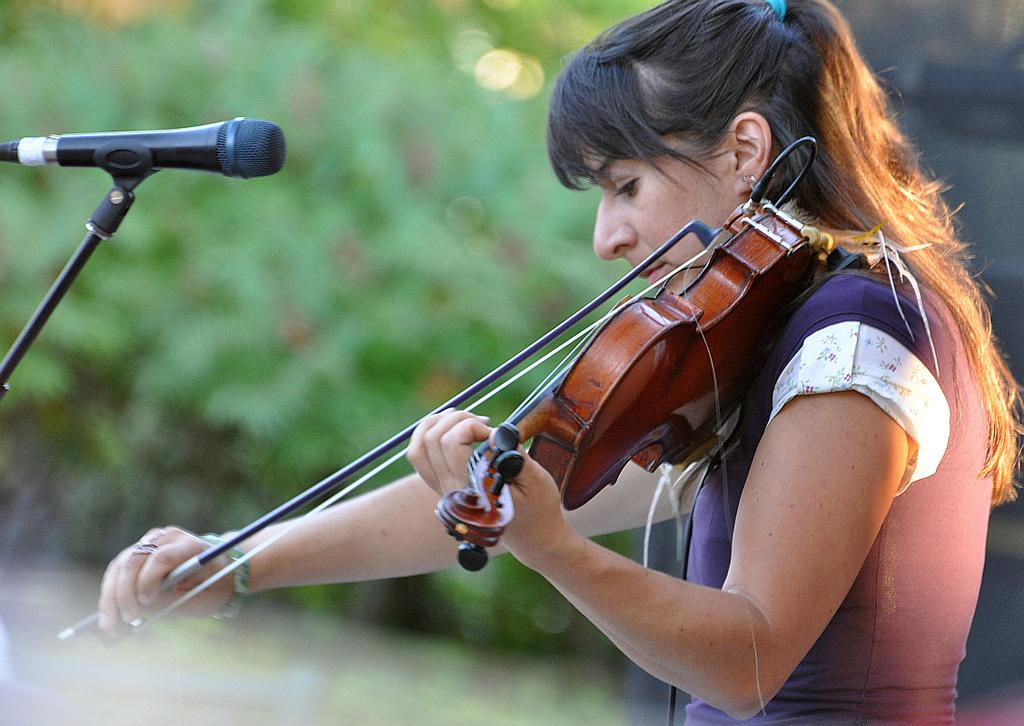What is the woman in the image doing? The woman is playing a violin in the image. Can you describe the setting of the image? The image features a woman playing a violin and a microphone stand on the left side. What might be the purpose of the microphone stand? The microphone stand might be used for amplifying the sound of the violin or for other audio purposes. What type of religion is being practiced in the image? There is no indication of any religious practice in the image; it features a woman playing a violin and a microphone stand. 